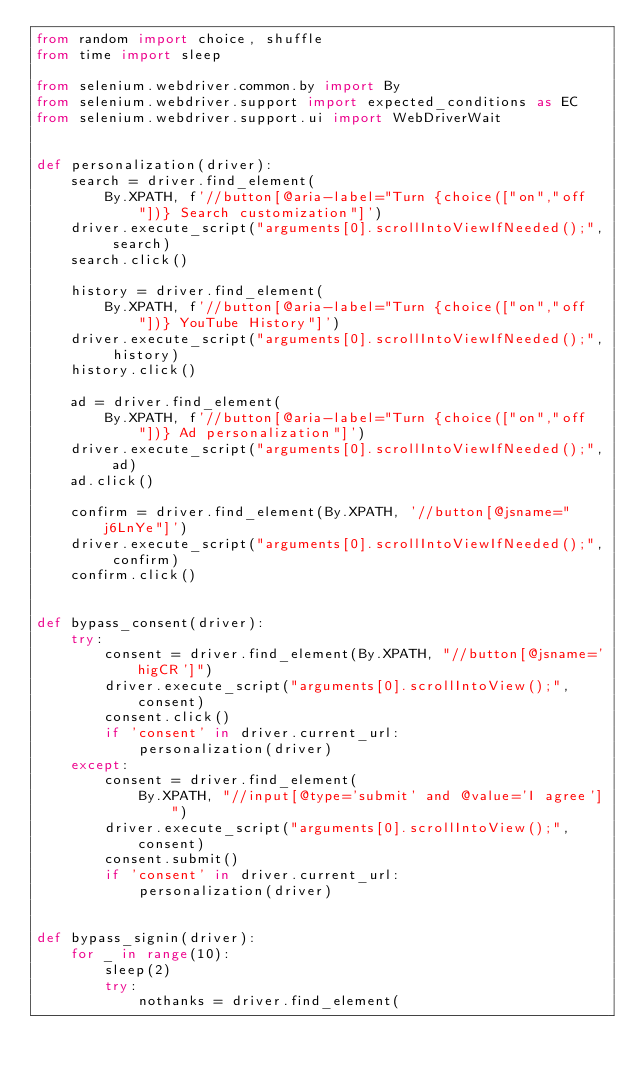Convert code to text. <code><loc_0><loc_0><loc_500><loc_500><_Python_>from random import choice, shuffle
from time import sleep

from selenium.webdriver.common.by import By
from selenium.webdriver.support import expected_conditions as EC
from selenium.webdriver.support.ui import WebDriverWait


def personalization(driver):
    search = driver.find_element(
        By.XPATH, f'//button[@aria-label="Turn {choice(["on","off"])} Search customization"]')
    driver.execute_script("arguments[0].scrollIntoViewIfNeeded();", search)
    search.click()

    history = driver.find_element(
        By.XPATH, f'//button[@aria-label="Turn {choice(["on","off"])} YouTube History"]')
    driver.execute_script("arguments[0].scrollIntoViewIfNeeded();", history)
    history.click()

    ad = driver.find_element(
        By.XPATH, f'//button[@aria-label="Turn {choice(["on","off"])} Ad personalization"]')
    driver.execute_script("arguments[0].scrollIntoViewIfNeeded();", ad)
    ad.click()

    confirm = driver.find_element(By.XPATH, '//button[@jsname="j6LnYe"]')
    driver.execute_script("arguments[0].scrollIntoViewIfNeeded();", confirm)
    confirm.click()


def bypass_consent(driver):
    try:
        consent = driver.find_element(By.XPATH, "//button[@jsname='higCR']")
        driver.execute_script("arguments[0].scrollIntoView();", consent)
        consent.click()
        if 'consent' in driver.current_url:
            personalization(driver)
    except:
        consent = driver.find_element(
            By.XPATH, "//input[@type='submit' and @value='I agree']")
        driver.execute_script("arguments[0].scrollIntoView();", consent)
        consent.submit()
        if 'consent' in driver.current_url:
            personalization(driver)


def bypass_signin(driver):
    for _ in range(10):
        sleep(2)
        try:
            nothanks = driver.find_element(</code> 